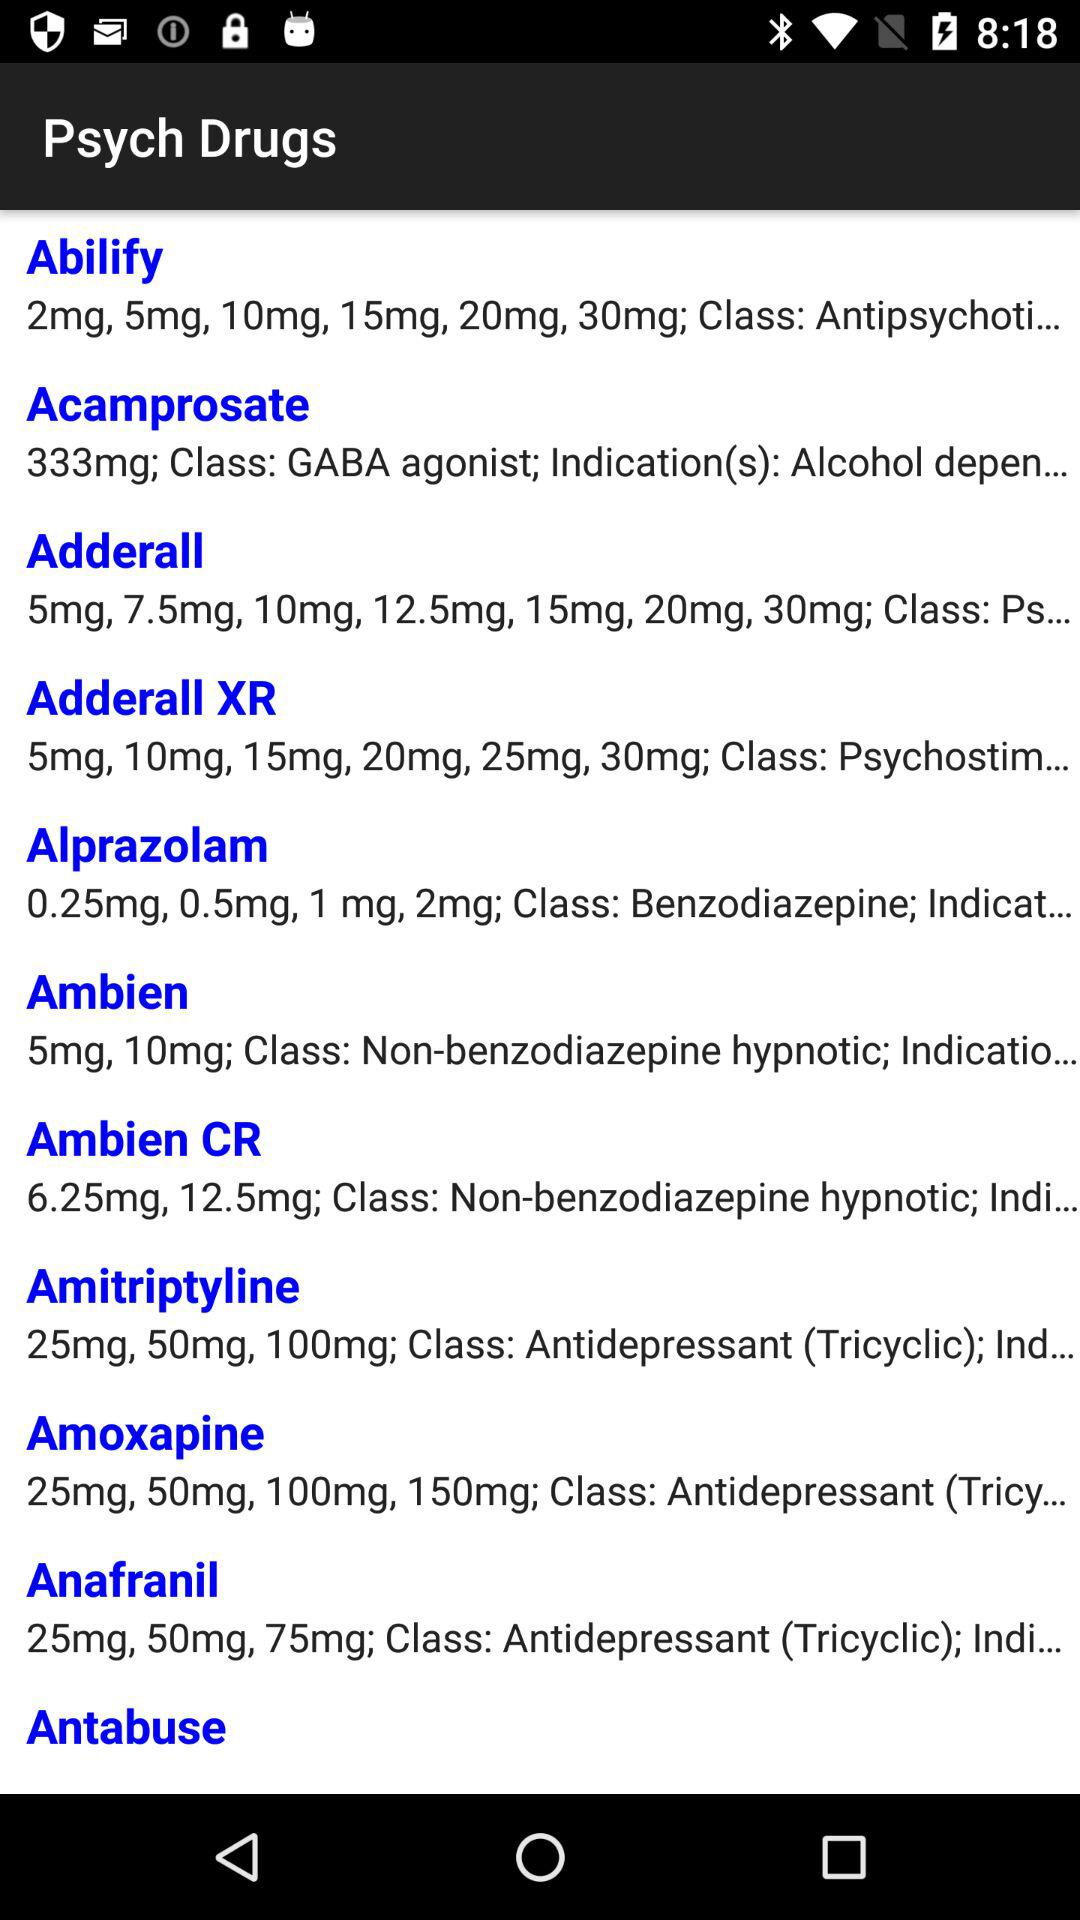What is the class of "Ambien" psych drugs? The class is "Non-benzodiazepine hypnotic". 